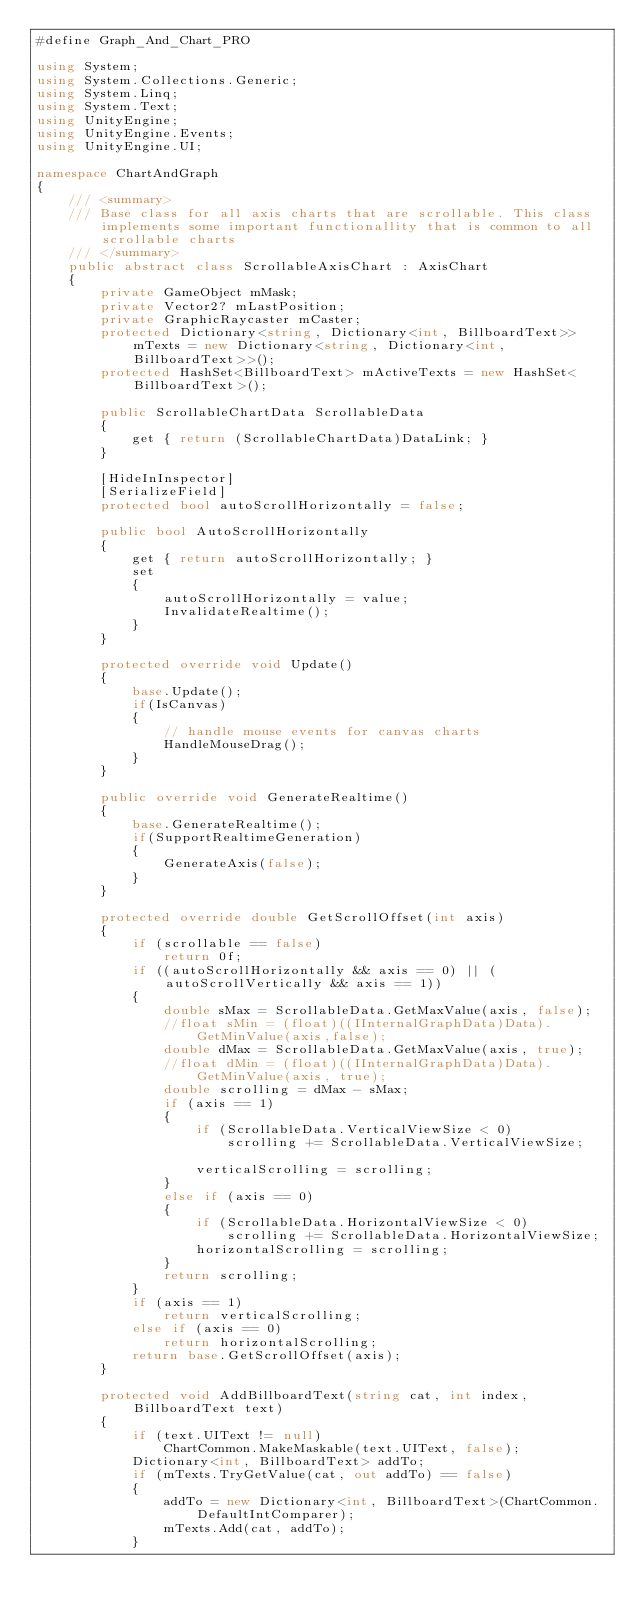<code> <loc_0><loc_0><loc_500><loc_500><_C#_>#define Graph_And_Chart_PRO

using System;
using System.Collections.Generic;
using System.Linq;
using System.Text;
using UnityEngine;
using UnityEngine.Events;
using UnityEngine.UI;

namespace ChartAndGraph
{
    /// <summary>
    /// Base class for all axis charts that are scrollable. This class implements some important functionallity that is common to all scrollable charts
    /// </summary>
    public abstract class ScrollableAxisChart : AxisChart
    {
        private GameObject mMask;
        private Vector2? mLastPosition;
        private GraphicRaycaster mCaster;
        protected Dictionary<string, Dictionary<int, BillboardText>> mTexts = new Dictionary<string, Dictionary<int, BillboardText>>();
        protected HashSet<BillboardText> mActiveTexts = new HashSet<BillboardText>();

        public ScrollableChartData ScrollableData
        {
            get { return (ScrollableChartData)DataLink; }
        }

        [HideInInspector]
        [SerializeField]
        protected bool autoScrollHorizontally = false;

        public bool AutoScrollHorizontally
        {
            get { return autoScrollHorizontally; }
            set
            {
                autoScrollHorizontally = value;
                InvalidateRealtime();
            }
        }

        protected override void Update()
        {
            base.Update();
            if(IsCanvas)
            {
                // handle mouse events for canvas charts
                HandleMouseDrag();
            }
        }

        public override void GenerateRealtime()
        {
            base.GenerateRealtime();
            if(SupportRealtimeGeneration)
            {
                GenerateAxis(false);
            }
        }

        protected override double GetScrollOffset(int axis)
        {
            if (scrollable == false)
                return 0f;
            if ((autoScrollHorizontally && axis == 0) || (autoScrollVertically && axis == 1))
            {                
                double sMax = ScrollableData.GetMaxValue(axis, false);
                //float sMin = (float)((IInternalGraphData)Data).GetMinValue(axis,false);
                double dMax = ScrollableData.GetMaxValue(axis, true);
                //float dMin = (float)((IInternalGraphData)Data).GetMinValue(axis, true);
                double scrolling = dMax - sMax;
                if (axis == 1)
                {
                    if (ScrollableData.VerticalViewSize < 0)
                        scrolling += ScrollableData.VerticalViewSize;

                    verticalScrolling = scrolling;
                }
                else if (axis == 0)
                {
                    if (ScrollableData.HorizontalViewSize < 0)
                        scrolling += ScrollableData.HorizontalViewSize;
                    horizontalScrolling = scrolling;
                }
                return scrolling;
            }
            if (axis == 1)
                return verticalScrolling;
            else if (axis == 0)
                return horizontalScrolling;
            return base.GetScrollOffset(axis);
        }

        protected void AddBillboardText(string cat, int index, BillboardText text)
        {
            if (text.UIText != null)
                ChartCommon.MakeMaskable(text.UIText, false);
            Dictionary<int, BillboardText> addTo;
            if (mTexts.TryGetValue(cat, out addTo) == false)
            {
                addTo = new Dictionary<int, BillboardText>(ChartCommon.DefaultIntComparer);
                mTexts.Add(cat, addTo);
            }</code> 